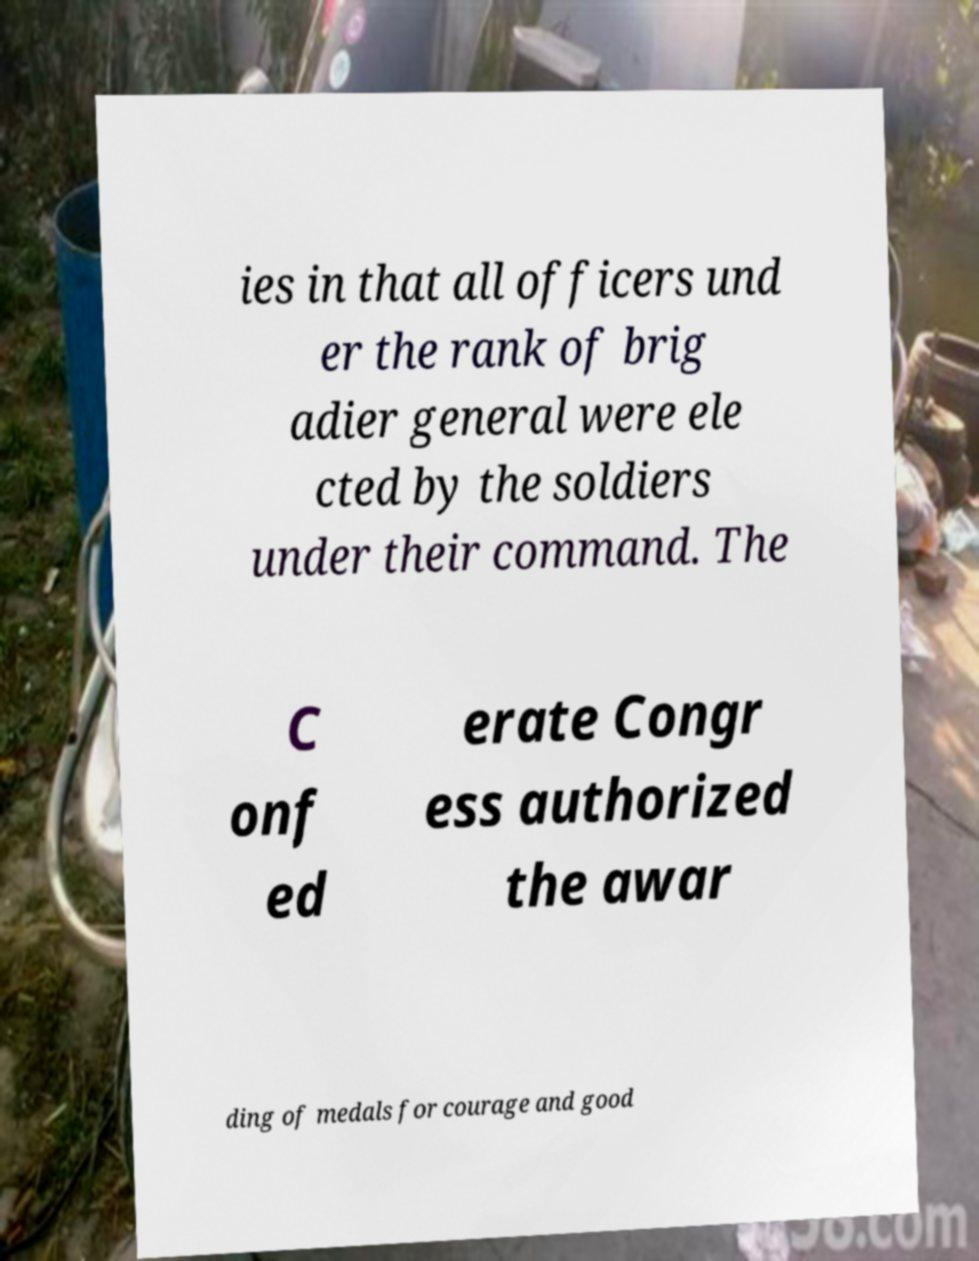Can you accurately transcribe the text from the provided image for me? ies in that all officers und er the rank of brig adier general were ele cted by the soldiers under their command. The C onf ed erate Congr ess authorized the awar ding of medals for courage and good 